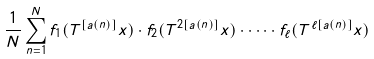Convert formula to latex. <formula><loc_0><loc_0><loc_500><loc_500>\frac { 1 } { N } \sum _ { n = 1 } ^ { N } f _ { 1 } ( T ^ { [ a ( n ) ] } x ) \cdot f _ { 2 } ( T ^ { 2 [ a ( n ) ] } x ) \cdot \dots \cdot f _ { \ell } ( T ^ { \ell [ a ( n ) ] } x )</formula> 